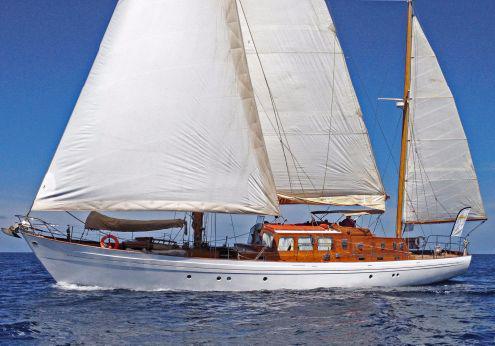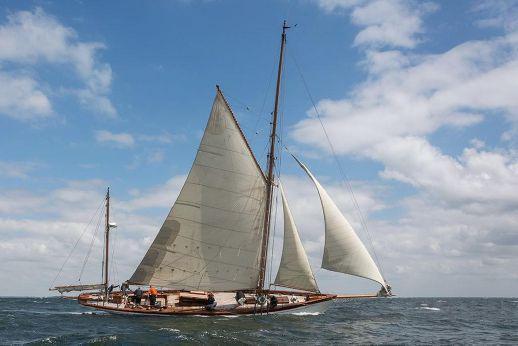The first image is the image on the left, the second image is the image on the right. Evaluate the accuracy of this statement regarding the images: "A boat on the water with three inflated sails is facing left". Is it true? Answer yes or no. Yes. 